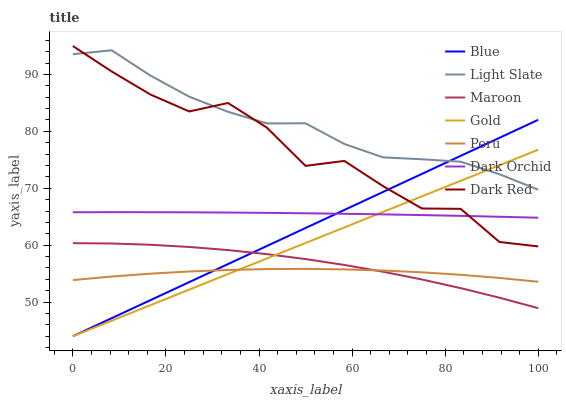Does Gold have the minimum area under the curve?
Answer yes or no. No. Does Gold have the maximum area under the curve?
Answer yes or no. No. Is Light Slate the smoothest?
Answer yes or no. No. Is Light Slate the roughest?
Answer yes or no. No. Does Light Slate have the lowest value?
Answer yes or no. No. Does Gold have the highest value?
Answer yes or no. No. Is Peru less than Light Slate?
Answer yes or no. Yes. Is Light Slate greater than Peru?
Answer yes or no. Yes. Does Peru intersect Light Slate?
Answer yes or no. No. 